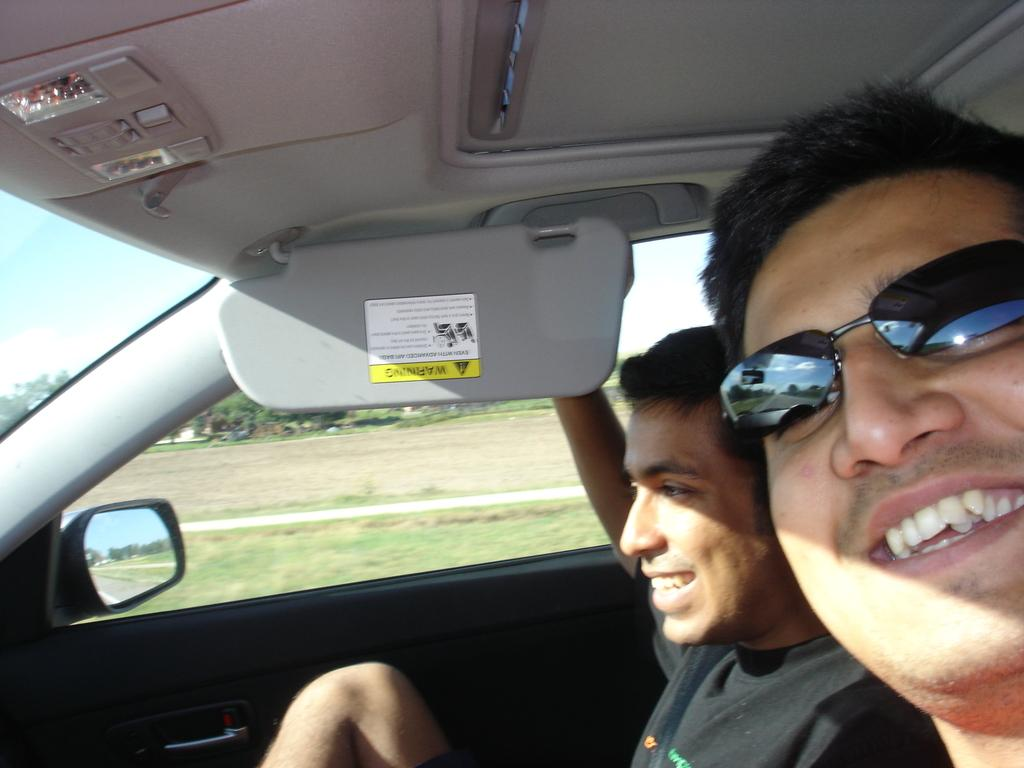How many people are in the car in the image? There are two persons sitting in the car. What can be seen through the car window? Trees, the ground, the sky, and a house are visible through the car window. What is the location of the house in relation to the car? The house is visible through the car window, but its exact location relative to the car cannot be determined from the image. What type of disease is affecting the car in the image? There is no indication of any disease affecting the car in the image. What body part of the persons in the car can be seen in the image? The image does not show any specific body parts of the persons in the car. 